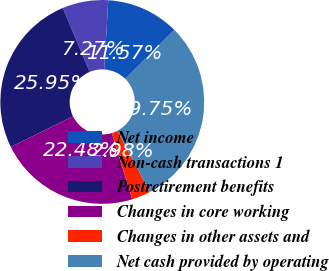Convert chart. <chart><loc_0><loc_0><loc_500><loc_500><pie_chart><fcel>Net income<fcel>Non-cash transactions 1<fcel>Postretirement benefits<fcel>Changes in core working<fcel>Changes in other assets and<fcel>Net cash provided by operating<nl><fcel>11.57%<fcel>7.27%<fcel>25.95%<fcel>22.48%<fcel>2.98%<fcel>29.75%<nl></chart> 